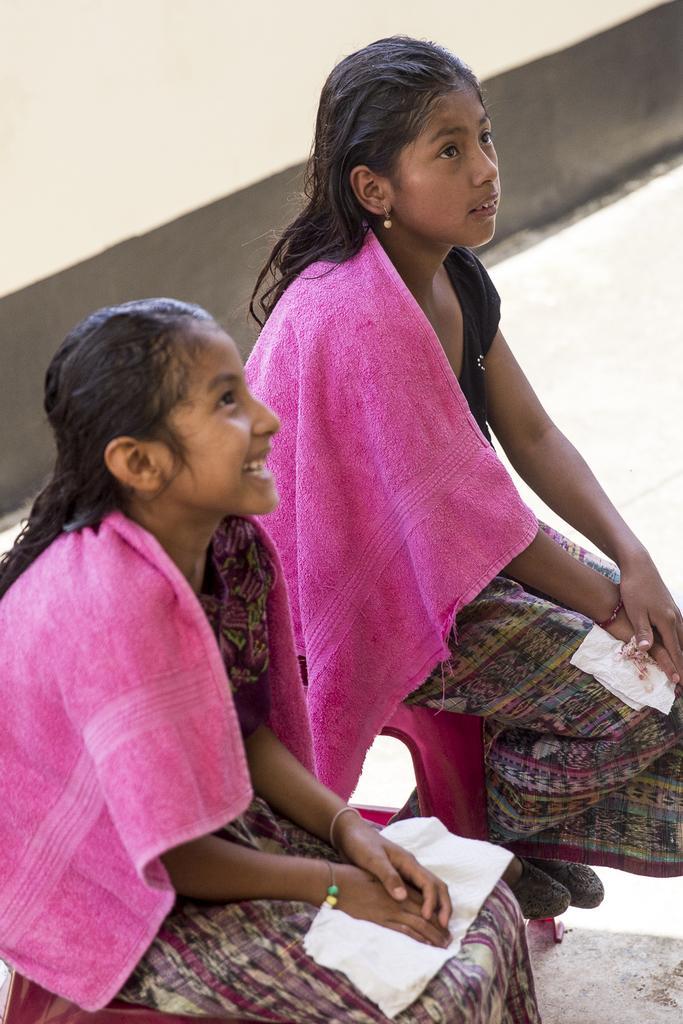Could you give a brief overview of what you see in this image? In this image I can see the two people with colorful dresses and the pink color towels. In the background I can see the floor. 